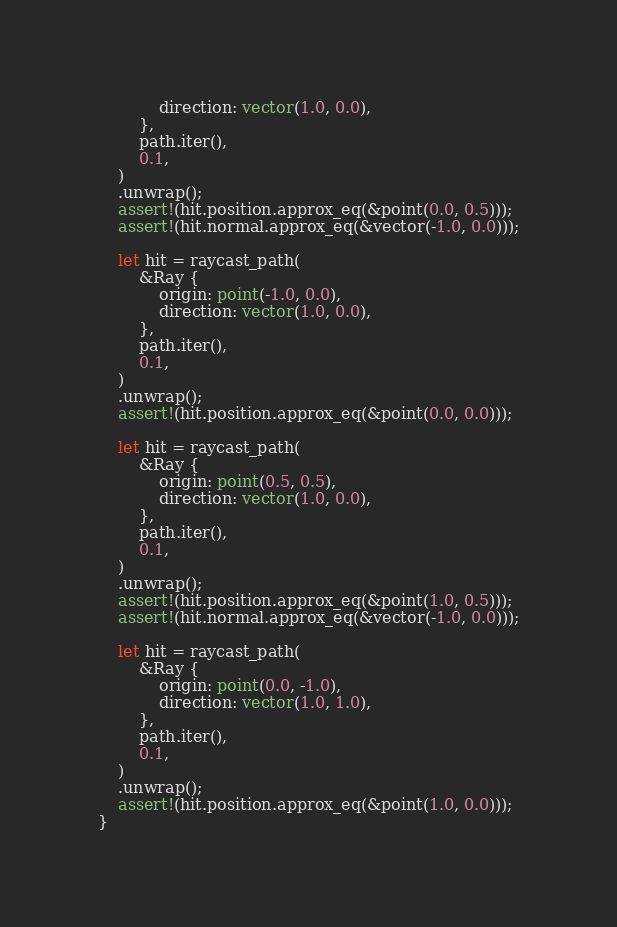Convert code to text. <code><loc_0><loc_0><loc_500><loc_500><_Rust_>            direction: vector(1.0, 0.0),
        },
        path.iter(),
        0.1,
    )
    .unwrap();
    assert!(hit.position.approx_eq(&point(0.0, 0.5)));
    assert!(hit.normal.approx_eq(&vector(-1.0, 0.0)));

    let hit = raycast_path(
        &Ray {
            origin: point(-1.0, 0.0),
            direction: vector(1.0, 0.0),
        },
        path.iter(),
        0.1,
    )
    .unwrap();
    assert!(hit.position.approx_eq(&point(0.0, 0.0)));

    let hit = raycast_path(
        &Ray {
            origin: point(0.5, 0.5),
            direction: vector(1.0, 0.0),
        },
        path.iter(),
        0.1,
    )
    .unwrap();
    assert!(hit.position.approx_eq(&point(1.0, 0.5)));
    assert!(hit.normal.approx_eq(&vector(-1.0, 0.0)));

    let hit = raycast_path(
        &Ray {
            origin: point(0.0, -1.0),
            direction: vector(1.0, 1.0),
        },
        path.iter(),
        0.1,
    )
    .unwrap();
    assert!(hit.position.approx_eq(&point(1.0, 0.0)));
}
</code> 